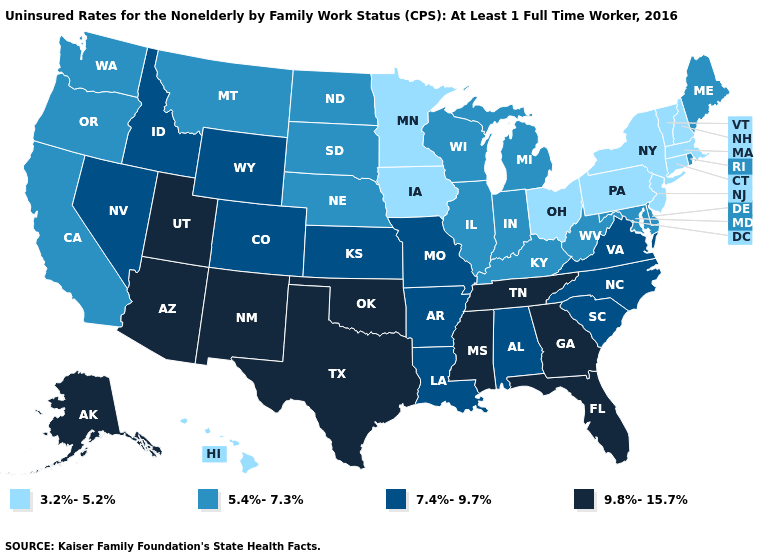Name the states that have a value in the range 7.4%-9.7%?
Concise answer only. Alabama, Arkansas, Colorado, Idaho, Kansas, Louisiana, Missouri, Nevada, North Carolina, South Carolina, Virginia, Wyoming. Name the states that have a value in the range 9.8%-15.7%?
Answer briefly. Alaska, Arizona, Florida, Georgia, Mississippi, New Mexico, Oklahoma, Tennessee, Texas, Utah. How many symbols are there in the legend?
Answer briefly. 4. Name the states that have a value in the range 5.4%-7.3%?
Give a very brief answer. California, Delaware, Illinois, Indiana, Kentucky, Maine, Maryland, Michigan, Montana, Nebraska, North Dakota, Oregon, Rhode Island, South Dakota, Washington, West Virginia, Wisconsin. Name the states that have a value in the range 3.2%-5.2%?
Be succinct. Connecticut, Hawaii, Iowa, Massachusetts, Minnesota, New Hampshire, New Jersey, New York, Ohio, Pennsylvania, Vermont. Does the first symbol in the legend represent the smallest category?
Quick response, please. Yes. What is the value of Indiana?
Quick response, please. 5.4%-7.3%. Among the states that border Iowa , which have the lowest value?
Be succinct. Minnesota. Does the first symbol in the legend represent the smallest category?
Answer briefly. Yes. Does Missouri have the highest value in the MidWest?
Concise answer only. Yes. What is the value of Arizona?
Give a very brief answer. 9.8%-15.7%. What is the value of Virginia?
Give a very brief answer. 7.4%-9.7%. What is the value of Georgia?
Give a very brief answer. 9.8%-15.7%. Among the states that border North Dakota , which have the lowest value?
Be succinct. Minnesota. What is the highest value in states that border Texas?
Keep it brief. 9.8%-15.7%. 